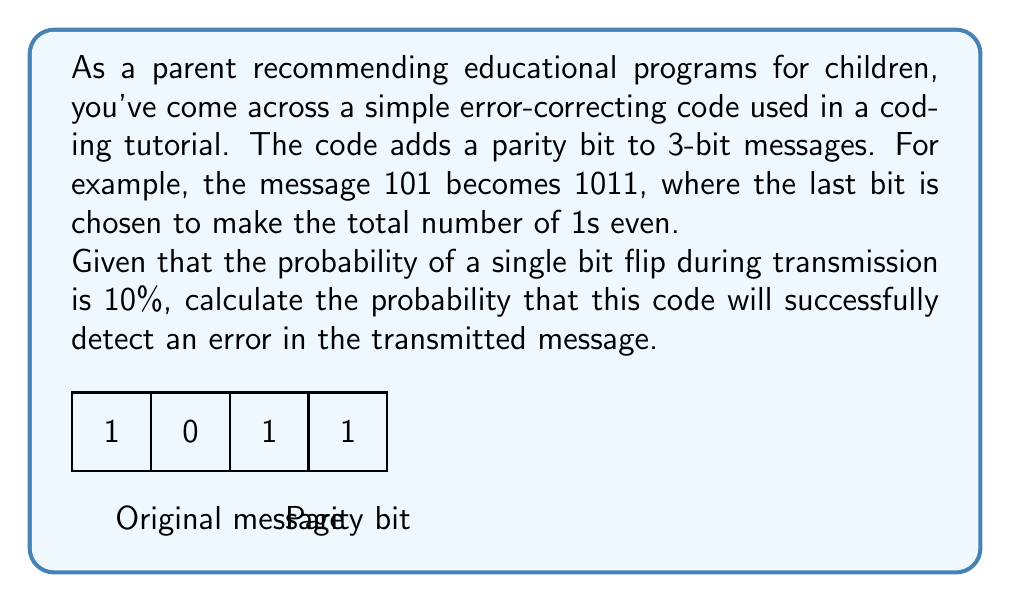Provide a solution to this math problem. Let's approach this step-by-step:

1) First, we need to understand when the code detects an error. It will detect an error when an odd number of bits are flipped.

2) The probability of a single bit flip is 10% or 0.1. So the probability of a bit not flipping is 90% or 0.9.

3) For a 4-bit message, we can have the following error scenarios:
   - 1 bit flips: $\binom{4}{1} \cdot 0.1 \cdot 0.9^3$
   - 3 bits flip: $\binom{4}{3} \cdot 0.1^3 \cdot 0.9^1$

4) Let's calculate each:
   - 1 bit flips: $4 \cdot 0.1 \cdot 0.9^3 = 4 \cdot 0.1 \cdot 0.729 = 0.2916$
   - 3 bits flip: $4 \cdot 0.1^3 \cdot 0.9 = 4 \cdot 0.001 \cdot 0.9 = 0.0036$

5) The total probability of detecting an error is the sum of these probabilities:

   $P(\text{detect error}) = 0.2916 + 0.0036 = 0.2952$

Therefore, the probability that this code will successfully detect an error is 0.2952 or about 29.52%.
Answer: 0.2952 